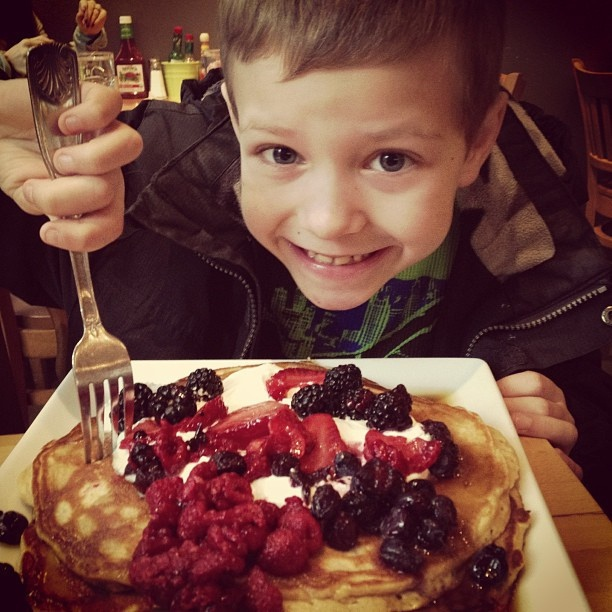Describe the objects in this image and their specific colors. I can see people in black, maroon, brown, and tan tones, pizza in black, maroon, and brown tones, fork in black, gray, maroon, and tan tones, dining table in black, brown, maroon, and salmon tones, and people in black, maroon, gray, and tan tones in this image. 